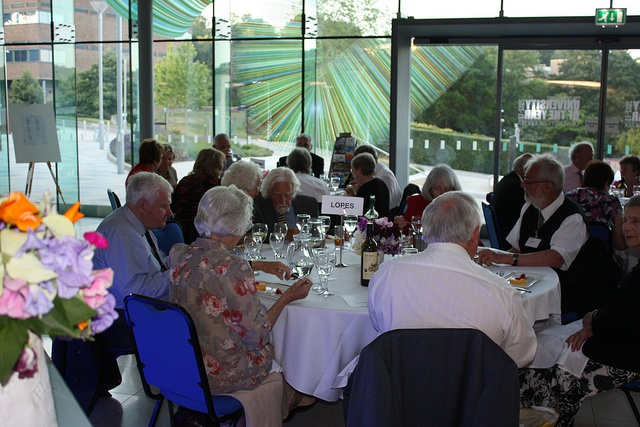Describe the objects in this image and their specific colors. I can see potted plant in lightblue, lightgray, darkgray, violet, and pink tones, people in lightblue, gray, maroon, and black tones, people in beige, darkgray, gray, maroon, and black tones, chair in lightblue, black, navy, and gray tones, and dining table in beige, darkgray, black, and gray tones in this image. 